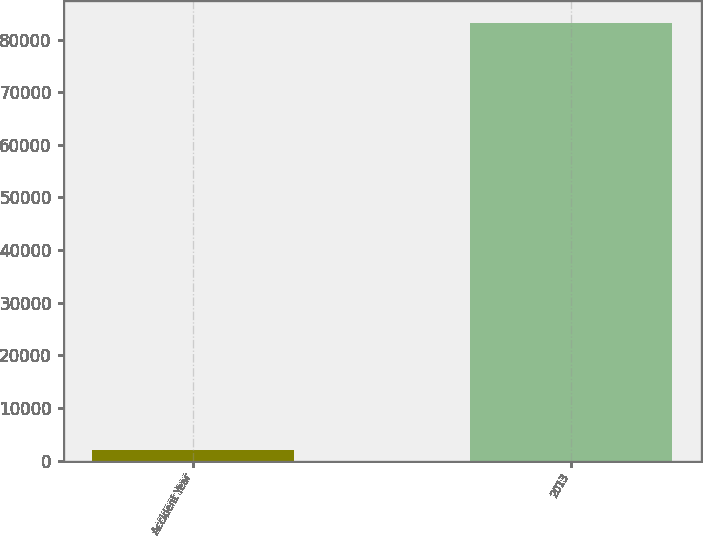Convert chart to OTSL. <chart><loc_0><loc_0><loc_500><loc_500><bar_chart><fcel>Accident Year<fcel>2013<nl><fcel>2017<fcel>83103<nl></chart> 